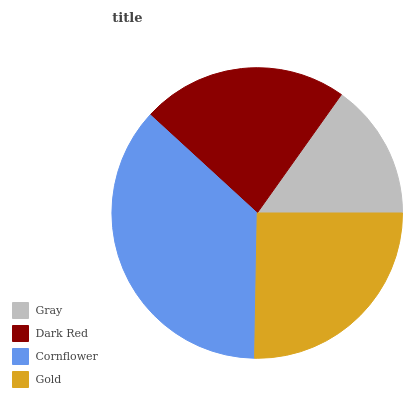Is Gray the minimum?
Answer yes or no. Yes. Is Cornflower the maximum?
Answer yes or no. Yes. Is Dark Red the minimum?
Answer yes or no. No. Is Dark Red the maximum?
Answer yes or no. No. Is Dark Red greater than Gray?
Answer yes or no. Yes. Is Gray less than Dark Red?
Answer yes or no. Yes. Is Gray greater than Dark Red?
Answer yes or no. No. Is Dark Red less than Gray?
Answer yes or no. No. Is Gold the high median?
Answer yes or no. Yes. Is Dark Red the low median?
Answer yes or no. Yes. Is Cornflower the high median?
Answer yes or no. No. Is Cornflower the low median?
Answer yes or no. No. 